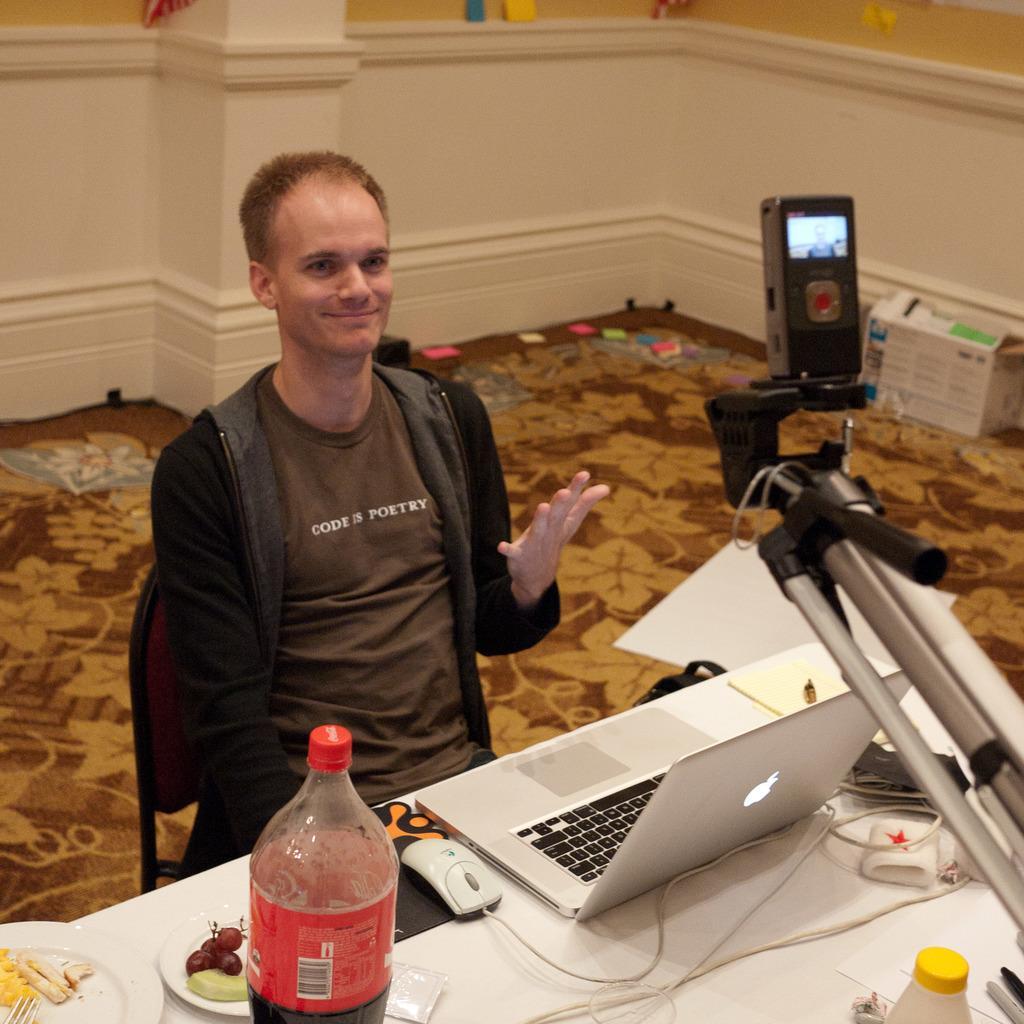Can you describe this image briefly? In this image we can see the boy sitting and smiling and also looking at some camera in front of him. He is showing his 5 fingers. It seems like he is in his house or something and in front of him there is a table in which there are things like laptop, drink bottle and food items containing plates, forks etc. In front of him there is a camera 